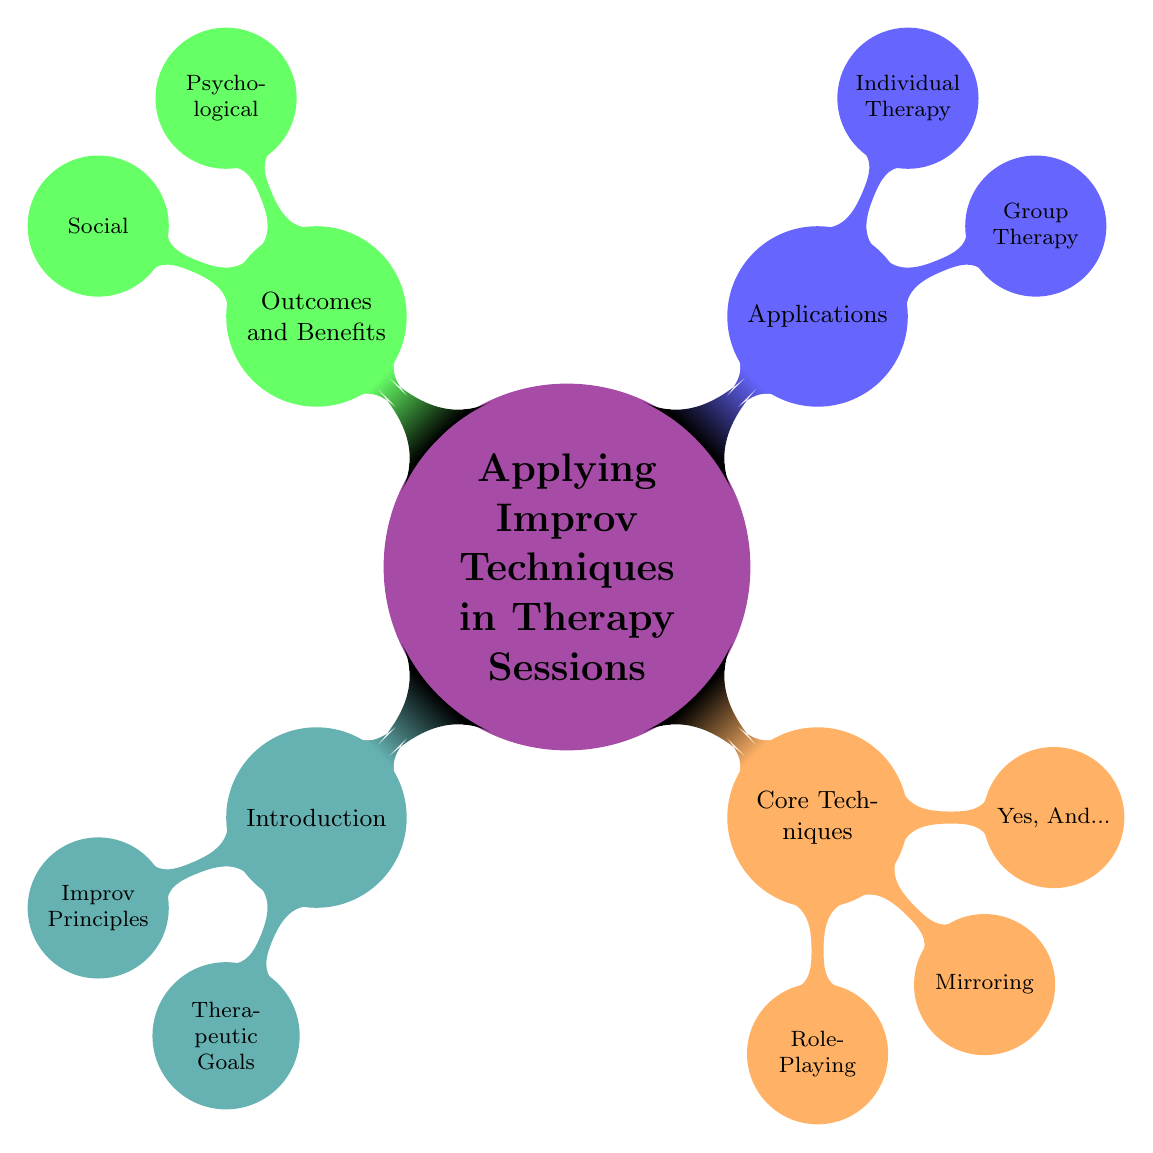What is the main topic of the mind map? The main topic is identified at the center of the diagram as "Applying Improv Techniques in Therapy Sessions."
Answer: Applying Improv Techniques in Therapy Sessions How many core techniques are listed in the diagram? The diagram shows three core techniques under the "Core Techniques" node: Role-Playing, Mirroring, and Yes, And...
Answer: 3 What principle encourages expansion on a partner's ideas? By looking at the "Improv Principles" node, the principle that encourages expansion is "Yes, And..."
Answer: Yes, And.. What is the purpose of group therapy as per the mind map? The purpose of group therapy can be taken from the "Purpose" section under the "Group Therapy" node: "Improving Group Dynamics," and "Building Trust among Participants."
Answer: Improving Group Dynamics Which technique enhances empathy according to the diagram? Within the "Benefits" of "Role-Playing," the enhancement of empathy is mentioned, indicating that this technique serves that purpose.
Answer: Role-Playing What are two psychological benefits listed in the mind map? The diagram specifies two psychological benefits: "Reduced Social Anxiety" and "Improved Emotional Regulation" under the "Psychological Benefits" node.
Answer: Reduced Social Anxiety, Improved Emotional Regulation How does "Mirroring" benefit participants? According to the diagram, "Mirroring" provides benefits of "Increased Emotional Awareness" and "Strengthened Nonverbal Communication."
Answer: Increased Emotional Awareness, Strengthened Nonverbal Communication What is a challenge therapists face when applying improv techniques? The challenges faced by therapists include "Specialized Training Required" and "Understanding Improv Dynamics," which are listed under "Therapist Training."
Answer: Specialized Training Required Which application is focused on personal growth? The application focused on personal growth is found under the "Individual Therapy" node, indicating its specific purpose.
Answer: Individual Therapy 